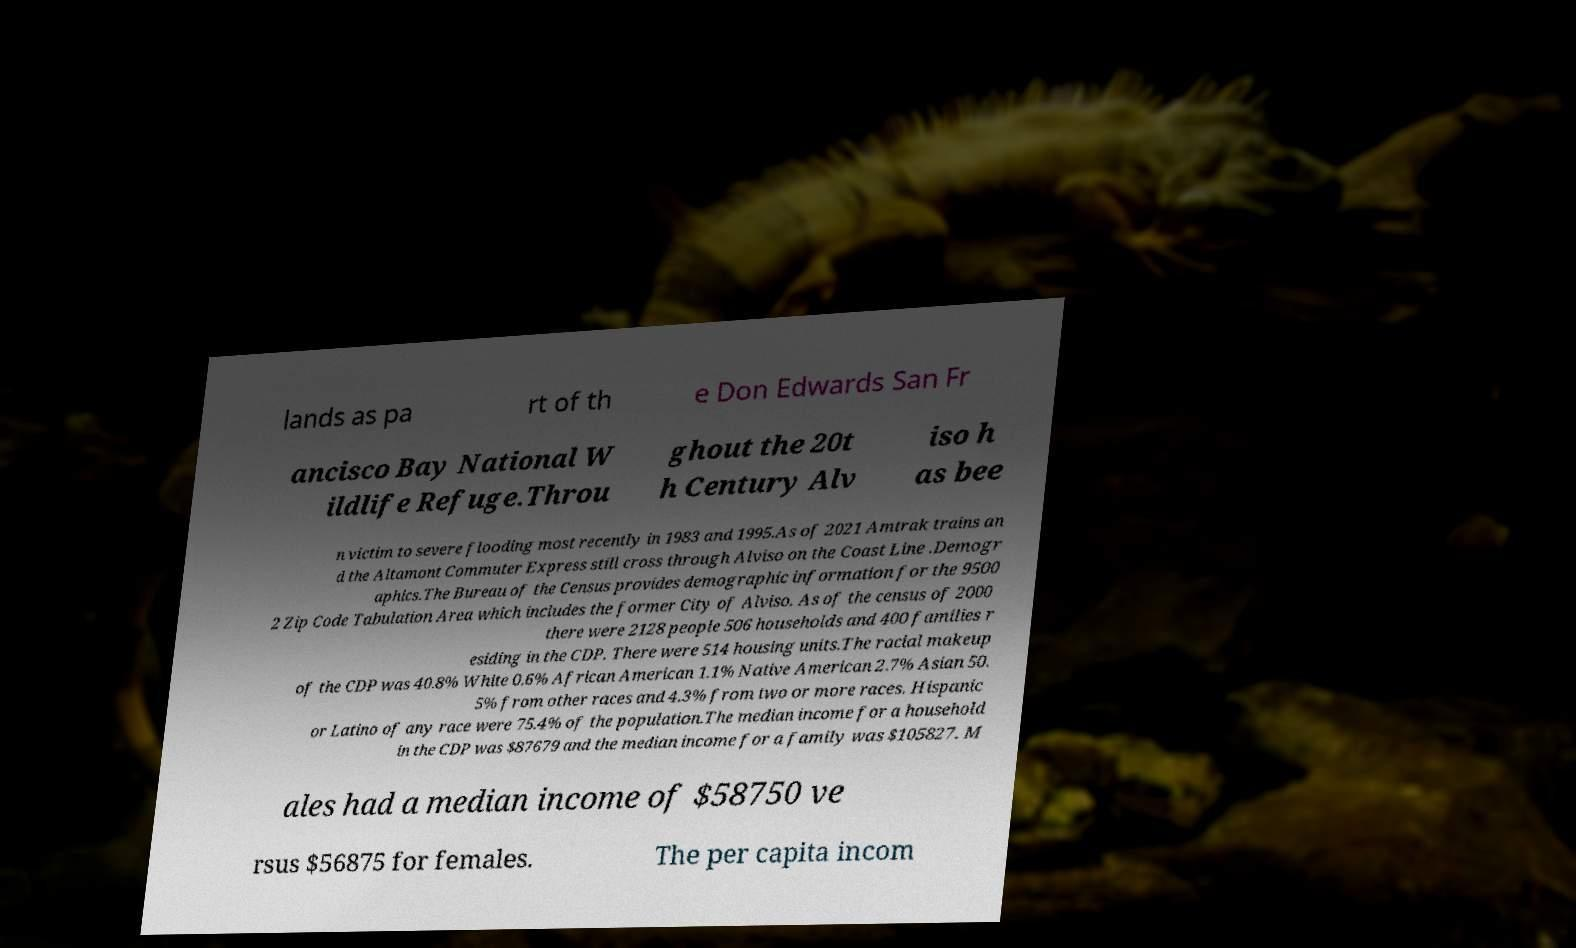What messages or text are displayed in this image? I need them in a readable, typed format. lands as pa rt of th e Don Edwards San Fr ancisco Bay National W ildlife Refuge.Throu ghout the 20t h Century Alv iso h as bee n victim to severe flooding most recently in 1983 and 1995.As of 2021 Amtrak trains an d the Altamont Commuter Express still cross through Alviso on the Coast Line .Demogr aphics.The Bureau of the Census provides demographic information for the 9500 2 Zip Code Tabulation Area which includes the former City of Alviso. As of the census of 2000 there were 2128 people 506 households and 400 families r esiding in the CDP. There were 514 housing units.The racial makeup of the CDP was 40.8% White 0.6% African American 1.1% Native American 2.7% Asian 50. 5% from other races and 4.3% from two or more races. Hispanic or Latino of any race were 75.4% of the population.The median income for a household in the CDP was $87679 and the median income for a family was $105827. M ales had a median income of $58750 ve rsus $56875 for females. The per capita incom 